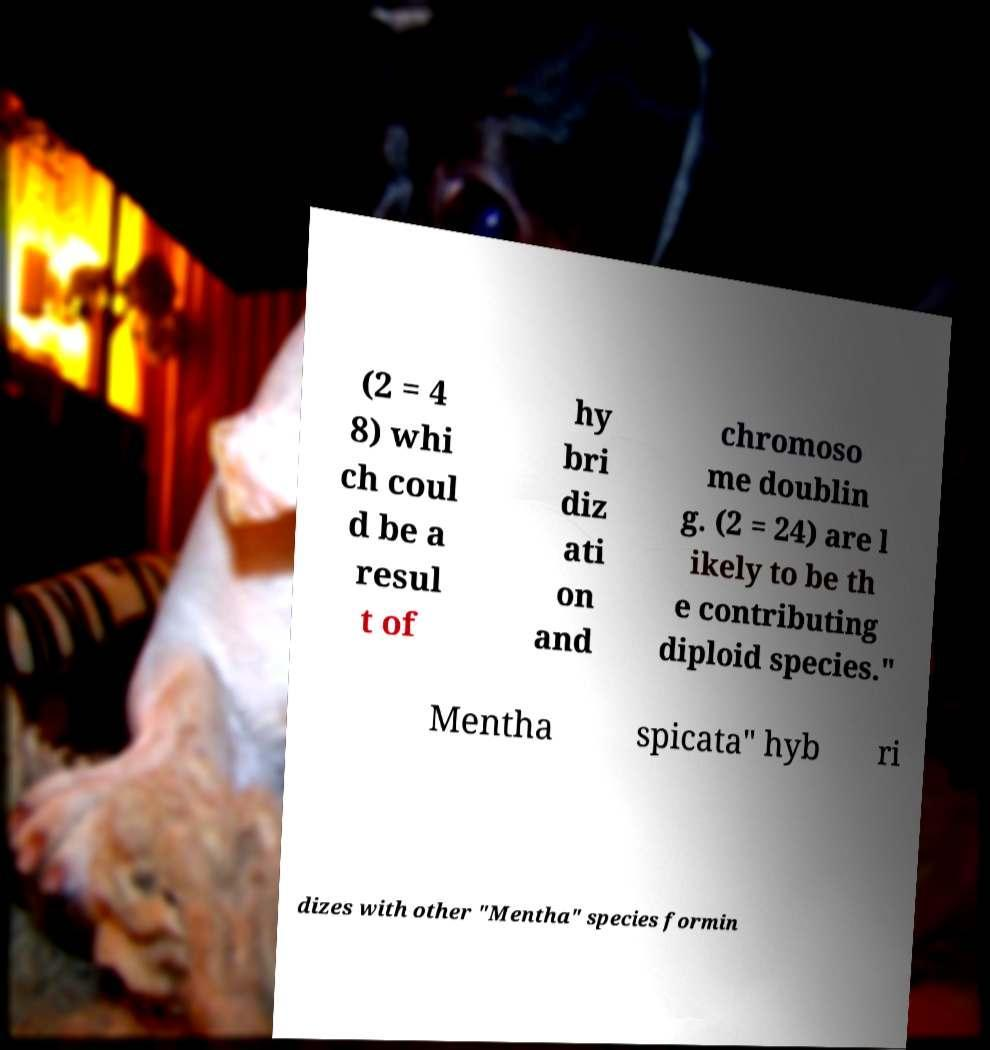Can you read and provide the text displayed in the image?This photo seems to have some interesting text. Can you extract and type it out for me? (2 = 4 8) whi ch coul d be a resul t of hy bri diz ati on and chromoso me doublin g. (2 = 24) are l ikely to be th e contributing diploid species." Mentha spicata" hyb ri dizes with other "Mentha" species formin 